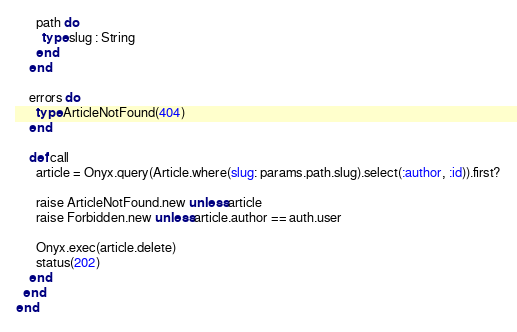<code> <loc_0><loc_0><loc_500><loc_500><_Crystal_>      path do
        type slug : String
      end
    end

    errors do
      type ArticleNotFound(404)
    end

    def call
      article = Onyx.query(Article.where(slug: params.path.slug).select(:author, :id)).first?

      raise ArticleNotFound.new unless article
      raise Forbidden.new unless article.author == auth.user

      Onyx.exec(article.delete)
      status(202)
    end
  end
end
</code> 